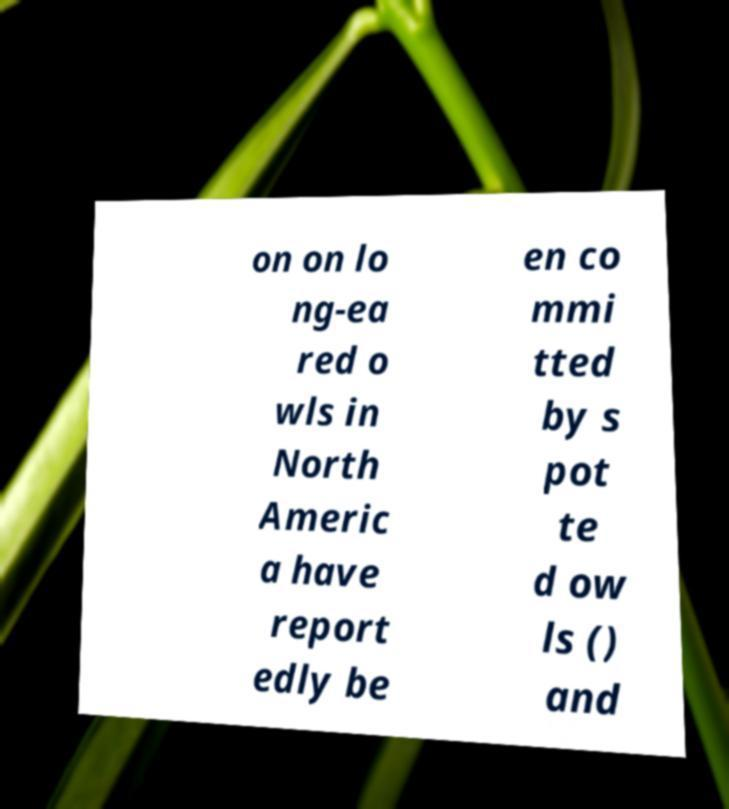Please read and relay the text visible in this image. What does it say? on on lo ng-ea red o wls in North Americ a have report edly be en co mmi tted by s pot te d ow ls () and 